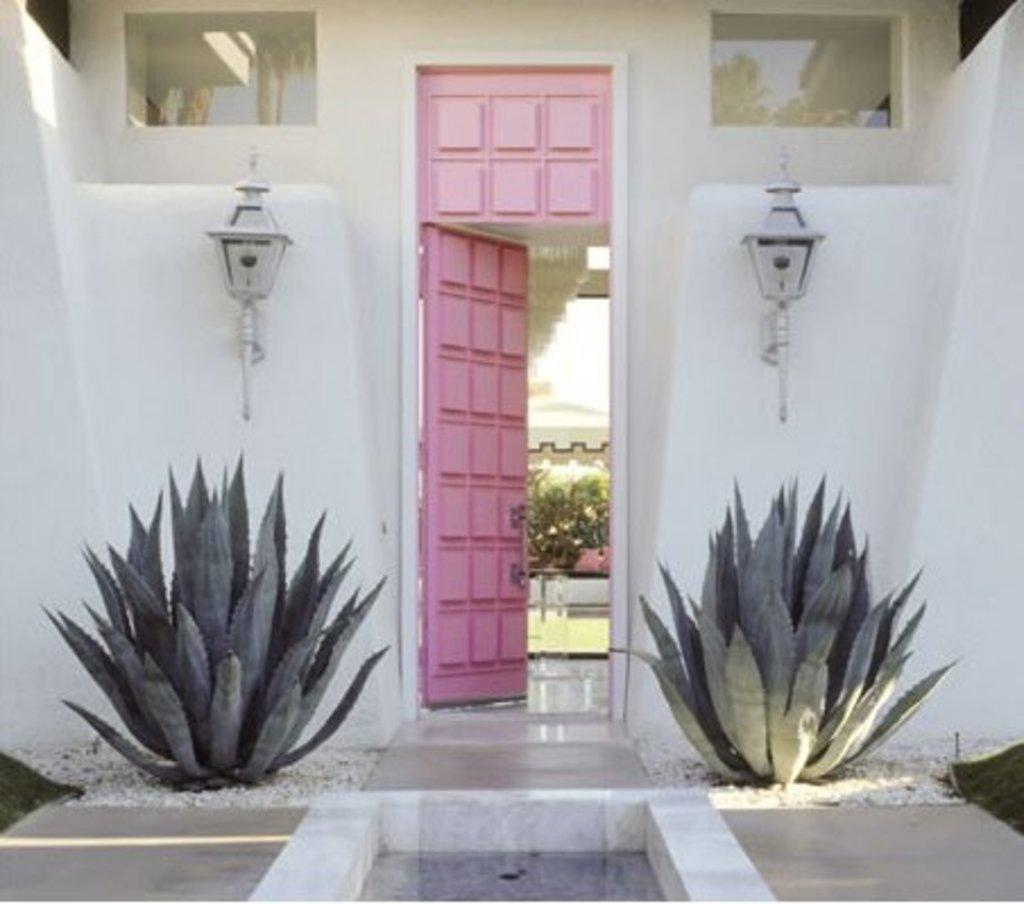What is one of the main features of the image? There is a door in the image. What type of vegetation can be seen in the image? There are plants and trees in the image. What material is present on the ground in the image? There are stones in the image. What type of lighting is present in the image? Electric lights are attached to the walls in the image. What is visible on the ground in the image? The ground is visible in the image. Where is the seat located in the image? There is no seat present in the image. What type of rail can be seen in the image? There is no rail present in the image. 